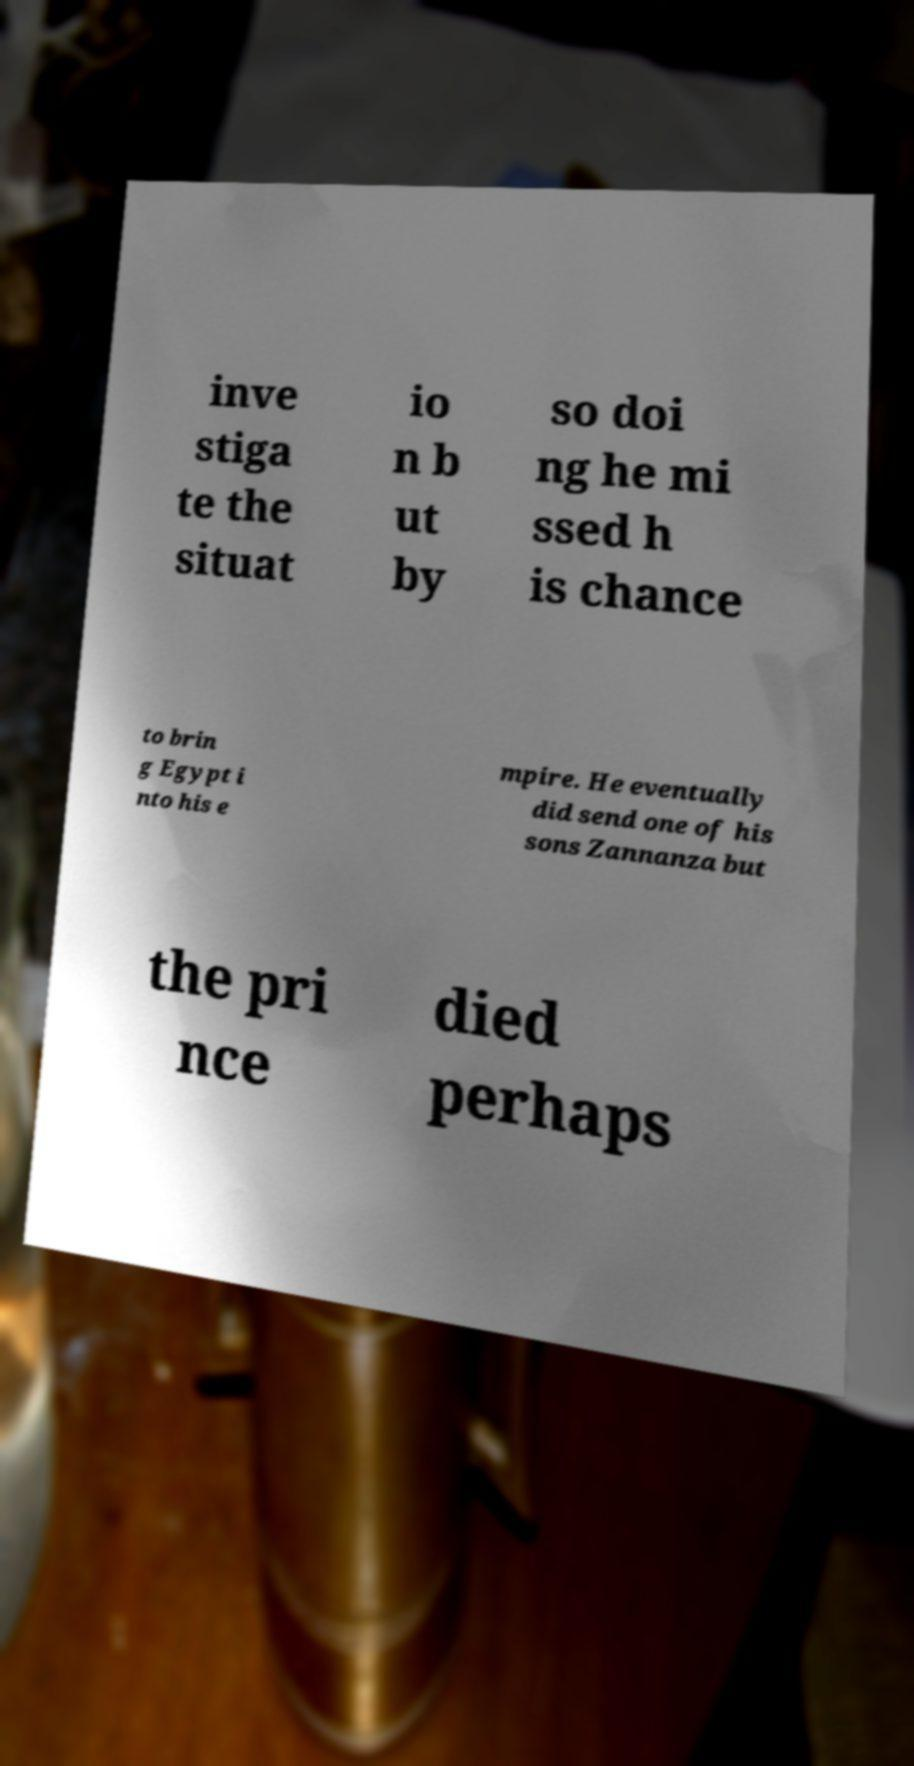Please read and relay the text visible in this image. What does it say? inve stiga te the situat io n b ut by so doi ng he mi ssed h is chance to brin g Egypt i nto his e mpire. He eventually did send one of his sons Zannanza but the pri nce died perhaps 